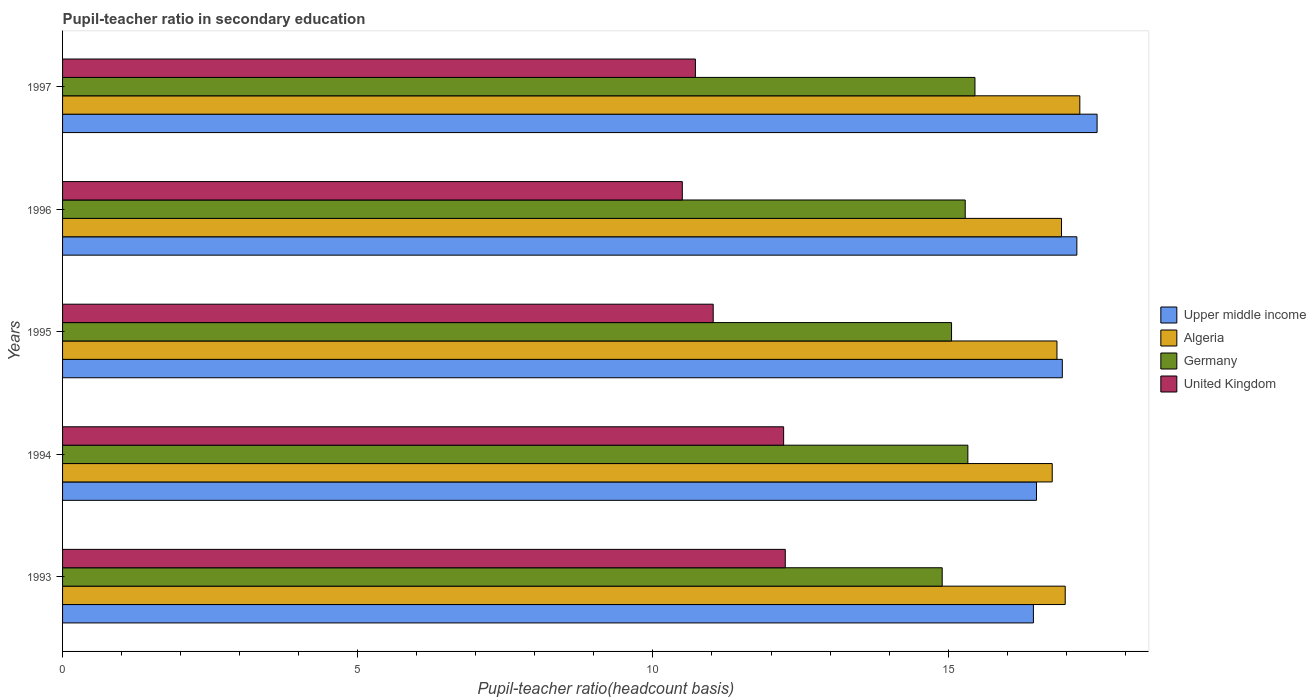How many different coloured bars are there?
Make the answer very short. 4. Are the number of bars per tick equal to the number of legend labels?
Offer a very short reply. Yes. In how many cases, is the number of bars for a given year not equal to the number of legend labels?
Provide a short and direct response. 0. What is the pupil-teacher ratio in secondary education in Algeria in 1997?
Offer a terse response. 17.23. Across all years, what is the maximum pupil-teacher ratio in secondary education in United Kingdom?
Ensure brevity in your answer.  12.24. Across all years, what is the minimum pupil-teacher ratio in secondary education in Upper middle income?
Provide a short and direct response. 16.44. In which year was the pupil-teacher ratio in secondary education in Upper middle income maximum?
Your answer should be compact. 1997. What is the total pupil-teacher ratio in secondary education in Algeria in the graph?
Your answer should be very brief. 84.74. What is the difference between the pupil-teacher ratio in secondary education in Germany in 1993 and that in 1995?
Ensure brevity in your answer.  -0.16. What is the difference between the pupil-teacher ratio in secondary education in Germany in 1994 and the pupil-teacher ratio in secondary education in Upper middle income in 1995?
Offer a very short reply. -1.6. What is the average pupil-teacher ratio in secondary education in United Kingdom per year?
Offer a terse response. 11.34. In the year 1996, what is the difference between the pupil-teacher ratio in secondary education in Germany and pupil-teacher ratio in secondary education in Algeria?
Give a very brief answer. -1.63. In how many years, is the pupil-teacher ratio in secondary education in Upper middle income greater than 10 ?
Keep it short and to the point. 5. What is the ratio of the pupil-teacher ratio in secondary education in Germany in 1993 to that in 1997?
Make the answer very short. 0.96. Is the difference between the pupil-teacher ratio in secondary education in Germany in 1994 and 1996 greater than the difference between the pupil-teacher ratio in secondary education in Algeria in 1994 and 1996?
Keep it short and to the point. Yes. What is the difference between the highest and the second highest pupil-teacher ratio in secondary education in Upper middle income?
Keep it short and to the point. 0.34. What is the difference between the highest and the lowest pupil-teacher ratio in secondary education in United Kingdom?
Offer a very short reply. 1.74. Is the sum of the pupil-teacher ratio in secondary education in United Kingdom in 1994 and 1997 greater than the maximum pupil-teacher ratio in secondary education in Upper middle income across all years?
Offer a terse response. Yes. Is it the case that in every year, the sum of the pupil-teacher ratio in secondary education in Upper middle income and pupil-teacher ratio in secondary education in Germany is greater than the sum of pupil-teacher ratio in secondary education in Algeria and pupil-teacher ratio in secondary education in United Kingdom?
Offer a very short reply. No. What does the 1st bar from the top in 1995 represents?
Your response must be concise. United Kingdom. How many years are there in the graph?
Keep it short and to the point. 5. Does the graph contain any zero values?
Offer a very short reply. No. Does the graph contain grids?
Make the answer very short. No. Where does the legend appear in the graph?
Make the answer very short. Center right. How many legend labels are there?
Keep it short and to the point. 4. What is the title of the graph?
Offer a very short reply. Pupil-teacher ratio in secondary education. What is the label or title of the X-axis?
Offer a terse response. Pupil-teacher ratio(headcount basis). What is the Pupil-teacher ratio(headcount basis) in Upper middle income in 1993?
Give a very brief answer. 16.44. What is the Pupil-teacher ratio(headcount basis) of Algeria in 1993?
Your answer should be compact. 16.98. What is the Pupil-teacher ratio(headcount basis) in Germany in 1993?
Ensure brevity in your answer.  14.9. What is the Pupil-teacher ratio(headcount basis) in United Kingdom in 1993?
Your response must be concise. 12.24. What is the Pupil-teacher ratio(headcount basis) in Upper middle income in 1994?
Your answer should be very brief. 16.5. What is the Pupil-teacher ratio(headcount basis) in Algeria in 1994?
Give a very brief answer. 16.76. What is the Pupil-teacher ratio(headcount basis) of Germany in 1994?
Your answer should be compact. 15.33. What is the Pupil-teacher ratio(headcount basis) of United Kingdom in 1994?
Ensure brevity in your answer.  12.21. What is the Pupil-teacher ratio(headcount basis) of Upper middle income in 1995?
Provide a succinct answer. 16.93. What is the Pupil-teacher ratio(headcount basis) of Algeria in 1995?
Offer a very short reply. 16.84. What is the Pupil-teacher ratio(headcount basis) of Germany in 1995?
Your answer should be very brief. 15.06. What is the Pupil-teacher ratio(headcount basis) of United Kingdom in 1995?
Offer a very short reply. 11.02. What is the Pupil-teacher ratio(headcount basis) in Upper middle income in 1996?
Keep it short and to the point. 17.18. What is the Pupil-teacher ratio(headcount basis) in Algeria in 1996?
Provide a succinct answer. 16.92. What is the Pupil-teacher ratio(headcount basis) of Germany in 1996?
Give a very brief answer. 15.29. What is the Pupil-teacher ratio(headcount basis) of United Kingdom in 1996?
Give a very brief answer. 10.5. What is the Pupil-teacher ratio(headcount basis) in Upper middle income in 1997?
Provide a succinct answer. 17.52. What is the Pupil-teacher ratio(headcount basis) of Algeria in 1997?
Offer a terse response. 17.23. What is the Pupil-teacher ratio(headcount basis) of Germany in 1997?
Offer a very short reply. 15.45. What is the Pupil-teacher ratio(headcount basis) of United Kingdom in 1997?
Keep it short and to the point. 10.72. Across all years, what is the maximum Pupil-teacher ratio(headcount basis) of Upper middle income?
Keep it short and to the point. 17.52. Across all years, what is the maximum Pupil-teacher ratio(headcount basis) of Algeria?
Your answer should be very brief. 17.23. Across all years, what is the maximum Pupil-teacher ratio(headcount basis) of Germany?
Ensure brevity in your answer.  15.45. Across all years, what is the maximum Pupil-teacher ratio(headcount basis) in United Kingdom?
Offer a terse response. 12.24. Across all years, what is the minimum Pupil-teacher ratio(headcount basis) in Upper middle income?
Keep it short and to the point. 16.44. Across all years, what is the minimum Pupil-teacher ratio(headcount basis) of Algeria?
Your answer should be compact. 16.76. Across all years, what is the minimum Pupil-teacher ratio(headcount basis) of Germany?
Offer a very short reply. 14.9. Across all years, what is the minimum Pupil-teacher ratio(headcount basis) of United Kingdom?
Offer a very short reply. 10.5. What is the total Pupil-teacher ratio(headcount basis) in Upper middle income in the graph?
Ensure brevity in your answer.  84.58. What is the total Pupil-teacher ratio(headcount basis) in Algeria in the graph?
Keep it short and to the point. 84.74. What is the total Pupil-teacher ratio(headcount basis) of Germany in the graph?
Your answer should be very brief. 76.04. What is the total Pupil-teacher ratio(headcount basis) in United Kingdom in the graph?
Your answer should be compact. 56.69. What is the difference between the Pupil-teacher ratio(headcount basis) of Upper middle income in 1993 and that in 1994?
Ensure brevity in your answer.  -0.05. What is the difference between the Pupil-teacher ratio(headcount basis) in Algeria in 1993 and that in 1994?
Provide a short and direct response. 0.22. What is the difference between the Pupil-teacher ratio(headcount basis) in Germany in 1993 and that in 1994?
Make the answer very short. -0.43. What is the difference between the Pupil-teacher ratio(headcount basis) in United Kingdom in 1993 and that in 1994?
Your answer should be very brief. 0.03. What is the difference between the Pupil-teacher ratio(headcount basis) of Upper middle income in 1993 and that in 1995?
Keep it short and to the point. -0.49. What is the difference between the Pupil-teacher ratio(headcount basis) of Algeria in 1993 and that in 1995?
Your response must be concise. 0.14. What is the difference between the Pupil-teacher ratio(headcount basis) of Germany in 1993 and that in 1995?
Your answer should be compact. -0.16. What is the difference between the Pupil-teacher ratio(headcount basis) in United Kingdom in 1993 and that in 1995?
Your answer should be compact. 1.22. What is the difference between the Pupil-teacher ratio(headcount basis) of Upper middle income in 1993 and that in 1996?
Your response must be concise. -0.74. What is the difference between the Pupil-teacher ratio(headcount basis) in Algeria in 1993 and that in 1996?
Offer a terse response. 0.06. What is the difference between the Pupil-teacher ratio(headcount basis) in Germany in 1993 and that in 1996?
Ensure brevity in your answer.  -0.39. What is the difference between the Pupil-teacher ratio(headcount basis) of United Kingdom in 1993 and that in 1996?
Offer a terse response. 1.74. What is the difference between the Pupil-teacher ratio(headcount basis) of Upper middle income in 1993 and that in 1997?
Your answer should be compact. -1.08. What is the difference between the Pupil-teacher ratio(headcount basis) of Algeria in 1993 and that in 1997?
Offer a very short reply. -0.25. What is the difference between the Pupil-teacher ratio(headcount basis) of Germany in 1993 and that in 1997?
Your response must be concise. -0.55. What is the difference between the Pupil-teacher ratio(headcount basis) of United Kingdom in 1993 and that in 1997?
Offer a terse response. 1.52. What is the difference between the Pupil-teacher ratio(headcount basis) of Upper middle income in 1994 and that in 1995?
Give a very brief answer. -0.44. What is the difference between the Pupil-teacher ratio(headcount basis) of Algeria in 1994 and that in 1995?
Offer a very short reply. -0.08. What is the difference between the Pupil-teacher ratio(headcount basis) in Germany in 1994 and that in 1995?
Offer a very short reply. 0.28. What is the difference between the Pupil-teacher ratio(headcount basis) of United Kingdom in 1994 and that in 1995?
Ensure brevity in your answer.  1.19. What is the difference between the Pupil-teacher ratio(headcount basis) of Upper middle income in 1994 and that in 1996?
Make the answer very short. -0.68. What is the difference between the Pupil-teacher ratio(headcount basis) in Algeria in 1994 and that in 1996?
Your answer should be very brief. -0.16. What is the difference between the Pupil-teacher ratio(headcount basis) of Germany in 1994 and that in 1996?
Your answer should be compact. 0.04. What is the difference between the Pupil-teacher ratio(headcount basis) of United Kingdom in 1994 and that in 1996?
Provide a short and direct response. 1.72. What is the difference between the Pupil-teacher ratio(headcount basis) of Upper middle income in 1994 and that in 1997?
Keep it short and to the point. -1.03. What is the difference between the Pupil-teacher ratio(headcount basis) in Algeria in 1994 and that in 1997?
Offer a terse response. -0.47. What is the difference between the Pupil-teacher ratio(headcount basis) of Germany in 1994 and that in 1997?
Offer a terse response. -0.12. What is the difference between the Pupil-teacher ratio(headcount basis) of United Kingdom in 1994 and that in 1997?
Provide a short and direct response. 1.49. What is the difference between the Pupil-teacher ratio(headcount basis) in Upper middle income in 1995 and that in 1996?
Your response must be concise. -0.25. What is the difference between the Pupil-teacher ratio(headcount basis) in Algeria in 1995 and that in 1996?
Provide a succinct answer. -0.08. What is the difference between the Pupil-teacher ratio(headcount basis) of Germany in 1995 and that in 1996?
Make the answer very short. -0.23. What is the difference between the Pupil-teacher ratio(headcount basis) in United Kingdom in 1995 and that in 1996?
Your answer should be compact. 0.52. What is the difference between the Pupil-teacher ratio(headcount basis) of Upper middle income in 1995 and that in 1997?
Offer a terse response. -0.59. What is the difference between the Pupil-teacher ratio(headcount basis) in Algeria in 1995 and that in 1997?
Your response must be concise. -0.39. What is the difference between the Pupil-teacher ratio(headcount basis) in Germany in 1995 and that in 1997?
Offer a very short reply. -0.4. What is the difference between the Pupil-teacher ratio(headcount basis) of United Kingdom in 1995 and that in 1997?
Your answer should be compact. 0.3. What is the difference between the Pupil-teacher ratio(headcount basis) of Upper middle income in 1996 and that in 1997?
Ensure brevity in your answer.  -0.34. What is the difference between the Pupil-teacher ratio(headcount basis) in Algeria in 1996 and that in 1997?
Provide a succinct answer. -0.31. What is the difference between the Pupil-teacher ratio(headcount basis) in Germany in 1996 and that in 1997?
Offer a very short reply. -0.16. What is the difference between the Pupil-teacher ratio(headcount basis) of United Kingdom in 1996 and that in 1997?
Ensure brevity in your answer.  -0.22. What is the difference between the Pupil-teacher ratio(headcount basis) of Upper middle income in 1993 and the Pupil-teacher ratio(headcount basis) of Algeria in 1994?
Your answer should be compact. -0.32. What is the difference between the Pupil-teacher ratio(headcount basis) in Upper middle income in 1993 and the Pupil-teacher ratio(headcount basis) in Germany in 1994?
Offer a terse response. 1.11. What is the difference between the Pupil-teacher ratio(headcount basis) of Upper middle income in 1993 and the Pupil-teacher ratio(headcount basis) of United Kingdom in 1994?
Keep it short and to the point. 4.23. What is the difference between the Pupil-teacher ratio(headcount basis) in Algeria in 1993 and the Pupil-teacher ratio(headcount basis) in Germany in 1994?
Give a very brief answer. 1.65. What is the difference between the Pupil-teacher ratio(headcount basis) of Algeria in 1993 and the Pupil-teacher ratio(headcount basis) of United Kingdom in 1994?
Your answer should be compact. 4.77. What is the difference between the Pupil-teacher ratio(headcount basis) of Germany in 1993 and the Pupil-teacher ratio(headcount basis) of United Kingdom in 1994?
Offer a terse response. 2.69. What is the difference between the Pupil-teacher ratio(headcount basis) of Upper middle income in 1993 and the Pupil-teacher ratio(headcount basis) of Algeria in 1995?
Give a very brief answer. -0.4. What is the difference between the Pupil-teacher ratio(headcount basis) in Upper middle income in 1993 and the Pupil-teacher ratio(headcount basis) in Germany in 1995?
Keep it short and to the point. 1.39. What is the difference between the Pupil-teacher ratio(headcount basis) in Upper middle income in 1993 and the Pupil-teacher ratio(headcount basis) in United Kingdom in 1995?
Give a very brief answer. 5.42. What is the difference between the Pupil-teacher ratio(headcount basis) in Algeria in 1993 and the Pupil-teacher ratio(headcount basis) in Germany in 1995?
Offer a very short reply. 1.93. What is the difference between the Pupil-teacher ratio(headcount basis) of Algeria in 1993 and the Pupil-teacher ratio(headcount basis) of United Kingdom in 1995?
Provide a short and direct response. 5.96. What is the difference between the Pupil-teacher ratio(headcount basis) in Germany in 1993 and the Pupil-teacher ratio(headcount basis) in United Kingdom in 1995?
Give a very brief answer. 3.88. What is the difference between the Pupil-teacher ratio(headcount basis) in Upper middle income in 1993 and the Pupil-teacher ratio(headcount basis) in Algeria in 1996?
Ensure brevity in your answer.  -0.48. What is the difference between the Pupil-teacher ratio(headcount basis) in Upper middle income in 1993 and the Pupil-teacher ratio(headcount basis) in Germany in 1996?
Your response must be concise. 1.15. What is the difference between the Pupil-teacher ratio(headcount basis) in Upper middle income in 1993 and the Pupil-teacher ratio(headcount basis) in United Kingdom in 1996?
Give a very brief answer. 5.95. What is the difference between the Pupil-teacher ratio(headcount basis) in Algeria in 1993 and the Pupil-teacher ratio(headcount basis) in Germany in 1996?
Your answer should be compact. 1.69. What is the difference between the Pupil-teacher ratio(headcount basis) in Algeria in 1993 and the Pupil-teacher ratio(headcount basis) in United Kingdom in 1996?
Your response must be concise. 6.49. What is the difference between the Pupil-teacher ratio(headcount basis) of Germany in 1993 and the Pupil-teacher ratio(headcount basis) of United Kingdom in 1996?
Ensure brevity in your answer.  4.4. What is the difference between the Pupil-teacher ratio(headcount basis) in Upper middle income in 1993 and the Pupil-teacher ratio(headcount basis) in Algeria in 1997?
Give a very brief answer. -0.79. What is the difference between the Pupil-teacher ratio(headcount basis) in Upper middle income in 1993 and the Pupil-teacher ratio(headcount basis) in Germany in 1997?
Offer a terse response. 0.99. What is the difference between the Pupil-teacher ratio(headcount basis) of Upper middle income in 1993 and the Pupil-teacher ratio(headcount basis) of United Kingdom in 1997?
Make the answer very short. 5.73. What is the difference between the Pupil-teacher ratio(headcount basis) in Algeria in 1993 and the Pupil-teacher ratio(headcount basis) in Germany in 1997?
Your answer should be very brief. 1.53. What is the difference between the Pupil-teacher ratio(headcount basis) in Algeria in 1993 and the Pupil-teacher ratio(headcount basis) in United Kingdom in 1997?
Give a very brief answer. 6.26. What is the difference between the Pupil-teacher ratio(headcount basis) in Germany in 1993 and the Pupil-teacher ratio(headcount basis) in United Kingdom in 1997?
Ensure brevity in your answer.  4.18. What is the difference between the Pupil-teacher ratio(headcount basis) of Upper middle income in 1994 and the Pupil-teacher ratio(headcount basis) of Algeria in 1995?
Provide a short and direct response. -0.35. What is the difference between the Pupil-teacher ratio(headcount basis) in Upper middle income in 1994 and the Pupil-teacher ratio(headcount basis) in Germany in 1995?
Your response must be concise. 1.44. What is the difference between the Pupil-teacher ratio(headcount basis) of Upper middle income in 1994 and the Pupil-teacher ratio(headcount basis) of United Kingdom in 1995?
Ensure brevity in your answer.  5.48. What is the difference between the Pupil-teacher ratio(headcount basis) in Algeria in 1994 and the Pupil-teacher ratio(headcount basis) in Germany in 1995?
Provide a short and direct response. 1.71. What is the difference between the Pupil-teacher ratio(headcount basis) in Algeria in 1994 and the Pupil-teacher ratio(headcount basis) in United Kingdom in 1995?
Offer a very short reply. 5.74. What is the difference between the Pupil-teacher ratio(headcount basis) in Germany in 1994 and the Pupil-teacher ratio(headcount basis) in United Kingdom in 1995?
Your response must be concise. 4.31. What is the difference between the Pupil-teacher ratio(headcount basis) in Upper middle income in 1994 and the Pupil-teacher ratio(headcount basis) in Algeria in 1996?
Give a very brief answer. -0.42. What is the difference between the Pupil-teacher ratio(headcount basis) in Upper middle income in 1994 and the Pupil-teacher ratio(headcount basis) in Germany in 1996?
Provide a short and direct response. 1.21. What is the difference between the Pupil-teacher ratio(headcount basis) in Upper middle income in 1994 and the Pupil-teacher ratio(headcount basis) in United Kingdom in 1996?
Make the answer very short. 6. What is the difference between the Pupil-teacher ratio(headcount basis) of Algeria in 1994 and the Pupil-teacher ratio(headcount basis) of Germany in 1996?
Your response must be concise. 1.47. What is the difference between the Pupil-teacher ratio(headcount basis) of Algeria in 1994 and the Pupil-teacher ratio(headcount basis) of United Kingdom in 1996?
Provide a succinct answer. 6.27. What is the difference between the Pupil-teacher ratio(headcount basis) in Germany in 1994 and the Pupil-teacher ratio(headcount basis) in United Kingdom in 1996?
Give a very brief answer. 4.84. What is the difference between the Pupil-teacher ratio(headcount basis) of Upper middle income in 1994 and the Pupil-teacher ratio(headcount basis) of Algeria in 1997?
Provide a short and direct response. -0.73. What is the difference between the Pupil-teacher ratio(headcount basis) in Upper middle income in 1994 and the Pupil-teacher ratio(headcount basis) in Germany in 1997?
Your answer should be very brief. 1.04. What is the difference between the Pupil-teacher ratio(headcount basis) of Upper middle income in 1994 and the Pupil-teacher ratio(headcount basis) of United Kingdom in 1997?
Offer a terse response. 5.78. What is the difference between the Pupil-teacher ratio(headcount basis) of Algeria in 1994 and the Pupil-teacher ratio(headcount basis) of Germany in 1997?
Provide a succinct answer. 1.31. What is the difference between the Pupil-teacher ratio(headcount basis) of Algeria in 1994 and the Pupil-teacher ratio(headcount basis) of United Kingdom in 1997?
Provide a short and direct response. 6.04. What is the difference between the Pupil-teacher ratio(headcount basis) in Germany in 1994 and the Pupil-teacher ratio(headcount basis) in United Kingdom in 1997?
Provide a short and direct response. 4.62. What is the difference between the Pupil-teacher ratio(headcount basis) in Upper middle income in 1995 and the Pupil-teacher ratio(headcount basis) in Algeria in 1996?
Your answer should be very brief. 0.01. What is the difference between the Pupil-teacher ratio(headcount basis) of Upper middle income in 1995 and the Pupil-teacher ratio(headcount basis) of Germany in 1996?
Ensure brevity in your answer.  1.64. What is the difference between the Pupil-teacher ratio(headcount basis) in Upper middle income in 1995 and the Pupil-teacher ratio(headcount basis) in United Kingdom in 1996?
Keep it short and to the point. 6.44. What is the difference between the Pupil-teacher ratio(headcount basis) of Algeria in 1995 and the Pupil-teacher ratio(headcount basis) of Germany in 1996?
Your answer should be compact. 1.55. What is the difference between the Pupil-teacher ratio(headcount basis) of Algeria in 1995 and the Pupil-teacher ratio(headcount basis) of United Kingdom in 1996?
Your answer should be very brief. 6.35. What is the difference between the Pupil-teacher ratio(headcount basis) in Germany in 1995 and the Pupil-teacher ratio(headcount basis) in United Kingdom in 1996?
Provide a succinct answer. 4.56. What is the difference between the Pupil-teacher ratio(headcount basis) in Upper middle income in 1995 and the Pupil-teacher ratio(headcount basis) in Algeria in 1997?
Give a very brief answer. -0.3. What is the difference between the Pupil-teacher ratio(headcount basis) of Upper middle income in 1995 and the Pupil-teacher ratio(headcount basis) of Germany in 1997?
Give a very brief answer. 1.48. What is the difference between the Pupil-teacher ratio(headcount basis) of Upper middle income in 1995 and the Pupil-teacher ratio(headcount basis) of United Kingdom in 1997?
Your response must be concise. 6.21. What is the difference between the Pupil-teacher ratio(headcount basis) of Algeria in 1995 and the Pupil-teacher ratio(headcount basis) of Germany in 1997?
Offer a very short reply. 1.39. What is the difference between the Pupil-teacher ratio(headcount basis) in Algeria in 1995 and the Pupil-teacher ratio(headcount basis) in United Kingdom in 1997?
Offer a terse response. 6.12. What is the difference between the Pupil-teacher ratio(headcount basis) in Germany in 1995 and the Pupil-teacher ratio(headcount basis) in United Kingdom in 1997?
Provide a short and direct response. 4.34. What is the difference between the Pupil-teacher ratio(headcount basis) in Upper middle income in 1996 and the Pupil-teacher ratio(headcount basis) in Algeria in 1997?
Your response must be concise. -0.05. What is the difference between the Pupil-teacher ratio(headcount basis) in Upper middle income in 1996 and the Pupil-teacher ratio(headcount basis) in Germany in 1997?
Ensure brevity in your answer.  1.73. What is the difference between the Pupil-teacher ratio(headcount basis) of Upper middle income in 1996 and the Pupil-teacher ratio(headcount basis) of United Kingdom in 1997?
Provide a succinct answer. 6.46. What is the difference between the Pupil-teacher ratio(headcount basis) of Algeria in 1996 and the Pupil-teacher ratio(headcount basis) of Germany in 1997?
Your answer should be very brief. 1.47. What is the difference between the Pupil-teacher ratio(headcount basis) in Algeria in 1996 and the Pupil-teacher ratio(headcount basis) in United Kingdom in 1997?
Offer a very short reply. 6.2. What is the difference between the Pupil-teacher ratio(headcount basis) of Germany in 1996 and the Pupil-teacher ratio(headcount basis) of United Kingdom in 1997?
Your response must be concise. 4.57. What is the average Pupil-teacher ratio(headcount basis) of Upper middle income per year?
Keep it short and to the point. 16.92. What is the average Pupil-teacher ratio(headcount basis) in Algeria per year?
Ensure brevity in your answer.  16.95. What is the average Pupil-teacher ratio(headcount basis) in Germany per year?
Give a very brief answer. 15.21. What is the average Pupil-teacher ratio(headcount basis) of United Kingdom per year?
Your answer should be compact. 11.34. In the year 1993, what is the difference between the Pupil-teacher ratio(headcount basis) in Upper middle income and Pupil-teacher ratio(headcount basis) in Algeria?
Your answer should be compact. -0.54. In the year 1993, what is the difference between the Pupil-teacher ratio(headcount basis) in Upper middle income and Pupil-teacher ratio(headcount basis) in Germany?
Keep it short and to the point. 1.54. In the year 1993, what is the difference between the Pupil-teacher ratio(headcount basis) in Upper middle income and Pupil-teacher ratio(headcount basis) in United Kingdom?
Your answer should be compact. 4.2. In the year 1993, what is the difference between the Pupil-teacher ratio(headcount basis) in Algeria and Pupil-teacher ratio(headcount basis) in Germany?
Make the answer very short. 2.08. In the year 1993, what is the difference between the Pupil-teacher ratio(headcount basis) in Algeria and Pupil-teacher ratio(headcount basis) in United Kingdom?
Ensure brevity in your answer.  4.74. In the year 1993, what is the difference between the Pupil-teacher ratio(headcount basis) of Germany and Pupil-teacher ratio(headcount basis) of United Kingdom?
Your answer should be compact. 2.66. In the year 1994, what is the difference between the Pupil-teacher ratio(headcount basis) of Upper middle income and Pupil-teacher ratio(headcount basis) of Algeria?
Your response must be concise. -0.27. In the year 1994, what is the difference between the Pupil-teacher ratio(headcount basis) in Upper middle income and Pupil-teacher ratio(headcount basis) in Germany?
Provide a short and direct response. 1.16. In the year 1994, what is the difference between the Pupil-teacher ratio(headcount basis) in Upper middle income and Pupil-teacher ratio(headcount basis) in United Kingdom?
Give a very brief answer. 4.28. In the year 1994, what is the difference between the Pupil-teacher ratio(headcount basis) in Algeria and Pupil-teacher ratio(headcount basis) in Germany?
Give a very brief answer. 1.43. In the year 1994, what is the difference between the Pupil-teacher ratio(headcount basis) in Algeria and Pupil-teacher ratio(headcount basis) in United Kingdom?
Provide a succinct answer. 4.55. In the year 1994, what is the difference between the Pupil-teacher ratio(headcount basis) of Germany and Pupil-teacher ratio(headcount basis) of United Kingdom?
Ensure brevity in your answer.  3.12. In the year 1995, what is the difference between the Pupil-teacher ratio(headcount basis) of Upper middle income and Pupil-teacher ratio(headcount basis) of Algeria?
Provide a short and direct response. 0.09. In the year 1995, what is the difference between the Pupil-teacher ratio(headcount basis) of Upper middle income and Pupil-teacher ratio(headcount basis) of Germany?
Offer a very short reply. 1.88. In the year 1995, what is the difference between the Pupil-teacher ratio(headcount basis) in Upper middle income and Pupil-teacher ratio(headcount basis) in United Kingdom?
Provide a short and direct response. 5.91. In the year 1995, what is the difference between the Pupil-teacher ratio(headcount basis) in Algeria and Pupil-teacher ratio(headcount basis) in Germany?
Your answer should be very brief. 1.79. In the year 1995, what is the difference between the Pupil-teacher ratio(headcount basis) in Algeria and Pupil-teacher ratio(headcount basis) in United Kingdom?
Provide a short and direct response. 5.82. In the year 1995, what is the difference between the Pupil-teacher ratio(headcount basis) of Germany and Pupil-teacher ratio(headcount basis) of United Kingdom?
Offer a terse response. 4.04. In the year 1996, what is the difference between the Pupil-teacher ratio(headcount basis) of Upper middle income and Pupil-teacher ratio(headcount basis) of Algeria?
Your answer should be very brief. 0.26. In the year 1996, what is the difference between the Pupil-teacher ratio(headcount basis) in Upper middle income and Pupil-teacher ratio(headcount basis) in Germany?
Ensure brevity in your answer.  1.89. In the year 1996, what is the difference between the Pupil-teacher ratio(headcount basis) in Upper middle income and Pupil-teacher ratio(headcount basis) in United Kingdom?
Your answer should be very brief. 6.68. In the year 1996, what is the difference between the Pupil-teacher ratio(headcount basis) of Algeria and Pupil-teacher ratio(headcount basis) of Germany?
Provide a short and direct response. 1.63. In the year 1996, what is the difference between the Pupil-teacher ratio(headcount basis) of Algeria and Pupil-teacher ratio(headcount basis) of United Kingdom?
Offer a very short reply. 6.42. In the year 1996, what is the difference between the Pupil-teacher ratio(headcount basis) of Germany and Pupil-teacher ratio(headcount basis) of United Kingdom?
Provide a succinct answer. 4.79. In the year 1997, what is the difference between the Pupil-teacher ratio(headcount basis) in Upper middle income and Pupil-teacher ratio(headcount basis) in Algeria?
Your answer should be compact. 0.29. In the year 1997, what is the difference between the Pupil-teacher ratio(headcount basis) of Upper middle income and Pupil-teacher ratio(headcount basis) of Germany?
Your answer should be compact. 2.07. In the year 1997, what is the difference between the Pupil-teacher ratio(headcount basis) of Upper middle income and Pupil-teacher ratio(headcount basis) of United Kingdom?
Keep it short and to the point. 6.8. In the year 1997, what is the difference between the Pupil-teacher ratio(headcount basis) in Algeria and Pupil-teacher ratio(headcount basis) in Germany?
Your answer should be compact. 1.78. In the year 1997, what is the difference between the Pupil-teacher ratio(headcount basis) of Algeria and Pupil-teacher ratio(headcount basis) of United Kingdom?
Ensure brevity in your answer.  6.51. In the year 1997, what is the difference between the Pupil-teacher ratio(headcount basis) in Germany and Pupil-teacher ratio(headcount basis) in United Kingdom?
Offer a very short reply. 4.74. What is the ratio of the Pupil-teacher ratio(headcount basis) in Upper middle income in 1993 to that in 1994?
Keep it short and to the point. 1. What is the ratio of the Pupil-teacher ratio(headcount basis) in Algeria in 1993 to that in 1994?
Your answer should be compact. 1.01. What is the ratio of the Pupil-teacher ratio(headcount basis) of Germany in 1993 to that in 1994?
Offer a terse response. 0.97. What is the ratio of the Pupil-teacher ratio(headcount basis) of Upper middle income in 1993 to that in 1995?
Your answer should be compact. 0.97. What is the ratio of the Pupil-teacher ratio(headcount basis) of Algeria in 1993 to that in 1995?
Your response must be concise. 1.01. What is the ratio of the Pupil-teacher ratio(headcount basis) of Germany in 1993 to that in 1995?
Make the answer very short. 0.99. What is the ratio of the Pupil-teacher ratio(headcount basis) in United Kingdom in 1993 to that in 1995?
Offer a very short reply. 1.11. What is the ratio of the Pupil-teacher ratio(headcount basis) of Upper middle income in 1993 to that in 1996?
Offer a terse response. 0.96. What is the ratio of the Pupil-teacher ratio(headcount basis) of Germany in 1993 to that in 1996?
Keep it short and to the point. 0.97. What is the ratio of the Pupil-teacher ratio(headcount basis) of United Kingdom in 1993 to that in 1996?
Give a very brief answer. 1.17. What is the ratio of the Pupil-teacher ratio(headcount basis) of Upper middle income in 1993 to that in 1997?
Your answer should be compact. 0.94. What is the ratio of the Pupil-teacher ratio(headcount basis) in Algeria in 1993 to that in 1997?
Keep it short and to the point. 0.99. What is the ratio of the Pupil-teacher ratio(headcount basis) of Germany in 1993 to that in 1997?
Provide a short and direct response. 0.96. What is the ratio of the Pupil-teacher ratio(headcount basis) of United Kingdom in 1993 to that in 1997?
Make the answer very short. 1.14. What is the ratio of the Pupil-teacher ratio(headcount basis) in Upper middle income in 1994 to that in 1995?
Make the answer very short. 0.97. What is the ratio of the Pupil-teacher ratio(headcount basis) of Algeria in 1994 to that in 1995?
Give a very brief answer. 1. What is the ratio of the Pupil-teacher ratio(headcount basis) of Germany in 1994 to that in 1995?
Your answer should be very brief. 1.02. What is the ratio of the Pupil-teacher ratio(headcount basis) in United Kingdom in 1994 to that in 1995?
Offer a terse response. 1.11. What is the ratio of the Pupil-teacher ratio(headcount basis) in Upper middle income in 1994 to that in 1996?
Make the answer very short. 0.96. What is the ratio of the Pupil-teacher ratio(headcount basis) in Germany in 1994 to that in 1996?
Offer a terse response. 1. What is the ratio of the Pupil-teacher ratio(headcount basis) in United Kingdom in 1994 to that in 1996?
Offer a terse response. 1.16. What is the ratio of the Pupil-teacher ratio(headcount basis) of Upper middle income in 1994 to that in 1997?
Offer a very short reply. 0.94. What is the ratio of the Pupil-teacher ratio(headcount basis) in Algeria in 1994 to that in 1997?
Give a very brief answer. 0.97. What is the ratio of the Pupil-teacher ratio(headcount basis) in United Kingdom in 1994 to that in 1997?
Your response must be concise. 1.14. What is the ratio of the Pupil-teacher ratio(headcount basis) in Upper middle income in 1995 to that in 1996?
Provide a succinct answer. 0.99. What is the ratio of the Pupil-teacher ratio(headcount basis) of Algeria in 1995 to that in 1996?
Make the answer very short. 1. What is the ratio of the Pupil-teacher ratio(headcount basis) of Germany in 1995 to that in 1996?
Ensure brevity in your answer.  0.98. What is the ratio of the Pupil-teacher ratio(headcount basis) in United Kingdom in 1995 to that in 1996?
Provide a succinct answer. 1.05. What is the ratio of the Pupil-teacher ratio(headcount basis) of Upper middle income in 1995 to that in 1997?
Keep it short and to the point. 0.97. What is the ratio of the Pupil-teacher ratio(headcount basis) in Algeria in 1995 to that in 1997?
Your answer should be very brief. 0.98. What is the ratio of the Pupil-teacher ratio(headcount basis) in Germany in 1995 to that in 1997?
Your response must be concise. 0.97. What is the ratio of the Pupil-teacher ratio(headcount basis) in United Kingdom in 1995 to that in 1997?
Provide a succinct answer. 1.03. What is the ratio of the Pupil-teacher ratio(headcount basis) of Upper middle income in 1996 to that in 1997?
Your answer should be very brief. 0.98. What is the ratio of the Pupil-teacher ratio(headcount basis) of Algeria in 1996 to that in 1997?
Give a very brief answer. 0.98. What is the ratio of the Pupil-teacher ratio(headcount basis) in Germany in 1996 to that in 1997?
Give a very brief answer. 0.99. What is the ratio of the Pupil-teacher ratio(headcount basis) of United Kingdom in 1996 to that in 1997?
Ensure brevity in your answer.  0.98. What is the difference between the highest and the second highest Pupil-teacher ratio(headcount basis) in Upper middle income?
Your answer should be very brief. 0.34. What is the difference between the highest and the second highest Pupil-teacher ratio(headcount basis) of Algeria?
Keep it short and to the point. 0.25. What is the difference between the highest and the second highest Pupil-teacher ratio(headcount basis) of Germany?
Ensure brevity in your answer.  0.12. What is the difference between the highest and the second highest Pupil-teacher ratio(headcount basis) of United Kingdom?
Give a very brief answer. 0.03. What is the difference between the highest and the lowest Pupil-teacher ratio(headcount basis) of Upper middle income?
Provide a short and direct response. 1.08. What is the difference between the highest and the lowest Pupil-teacher ratio(headcount basis) of Algeria?
Offer a very short reply. 0.47. What is the difference between the highest and the lowest Pupil-teacher ratio(headcount basis) of Germany?
Your response must be concise. 0.55. What is the difference between the highest and the lowest Pupil-teacher ratio(headcount basis) in United Kingdom?
Ensure brevity in your answer.  1.74. 